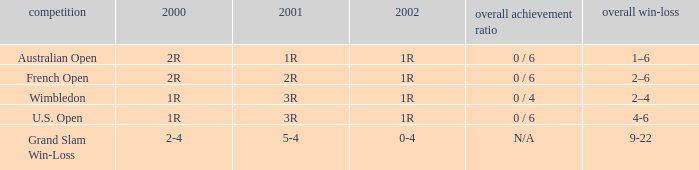In what year 2000 tournment did Angeles Montolio have a career win-loss record of 2-4? Grand Slam Win-Loss. 